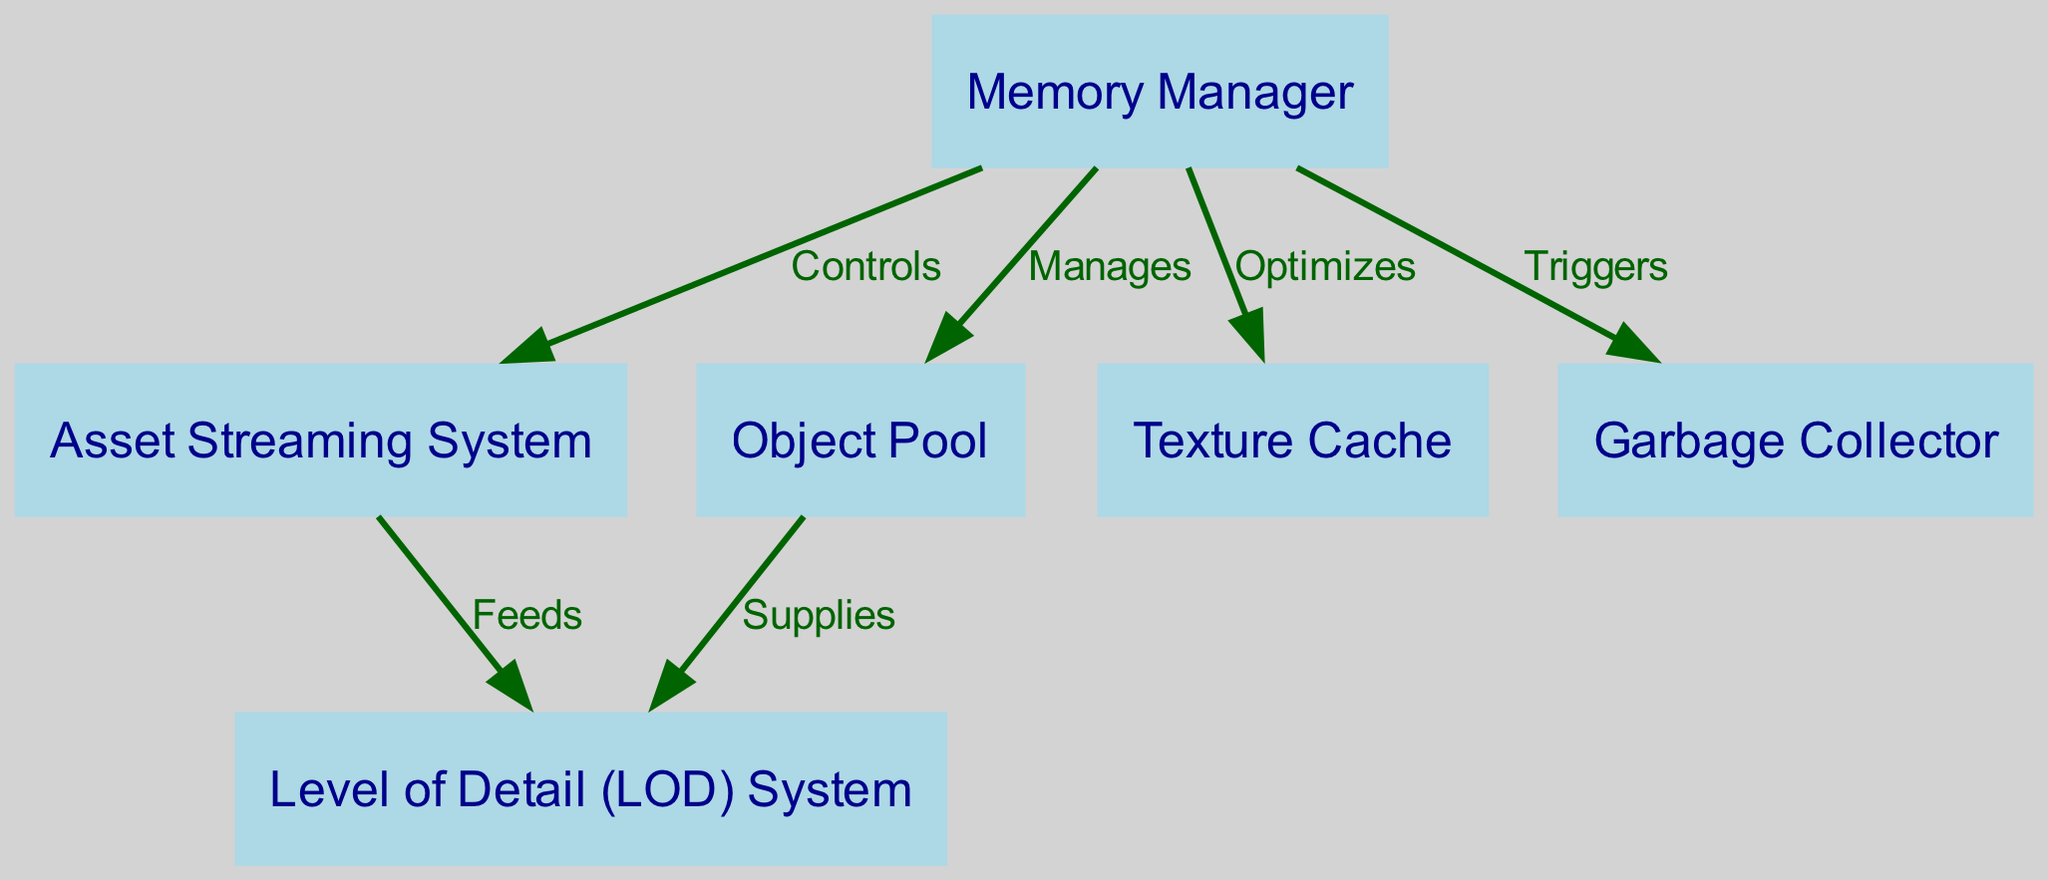What's the total number of nodes in the diagram? The diagram lists individual nodes, including the Memory Manager, Asset Streaming System, Object Pool, Texture Cache, Level of Detail System, and Garbage Collector. Counting these yields a total of 6 nodes.
Answer: 6 Which node does the Memory Manager optimize? By observing the edges connected to the Memory Manager, it has an edge labeled 'Optimizes' pointing to 'Texture Cache,' meaning that the Memory Manager optimizes the Texture Cache.
Answer: Texture Cache What relationship exists between the Asset Streaming System and the Level of Detail System? The Asset Streaming System has an outgoing edge labeled 'Feeds' that connects to the Level of Detail (LOD) System, indicating that the Asset Streaming System feeds data into the Level of Detail System.
Answer: Feeds How many edges are connected to the Object Pool? The Object Pool has one outgoing edge labeled 'Supplies' which points to the Level of Detail System. So, only one edge is connected to the Object Pool.
Answer: 1 Which node triggers the Garbage Collector? The edges indicate that the Memory Manager has an outgoing edge labeled 'Triggers' leading to the Garbage Collector. Therefore, the Memory Manager triggers the Garbage Collector.
Answer: Memory Manager What is the flow of control from the Memory Manager to the Asset Streaming System? The Memory Manager controls the Asset Streaming System as indicated by an edge labeled 'Controls' leading from the Memory Manager to the Asset Streaming System in the diagram.
Answer: Controls Which two nodes are directly connected? The Texture Cache and Memory Manager are directly connected by the 'Optimizes' edge, alongside other connections like Memory Manager to Asset Streaming System and Object Pool. Therefore, the Texture Cache and Memory Manager are directly connected.
Answer: Texture Cache, Memory Manager What is the main function of the Object Pool as seen in the diagram? The diagram shows that the Object Pool supplies data to the Level of Detail System, indicating its main function is to provide necessary objects for detail management.
Answer: Supplies to Level of Detail System 